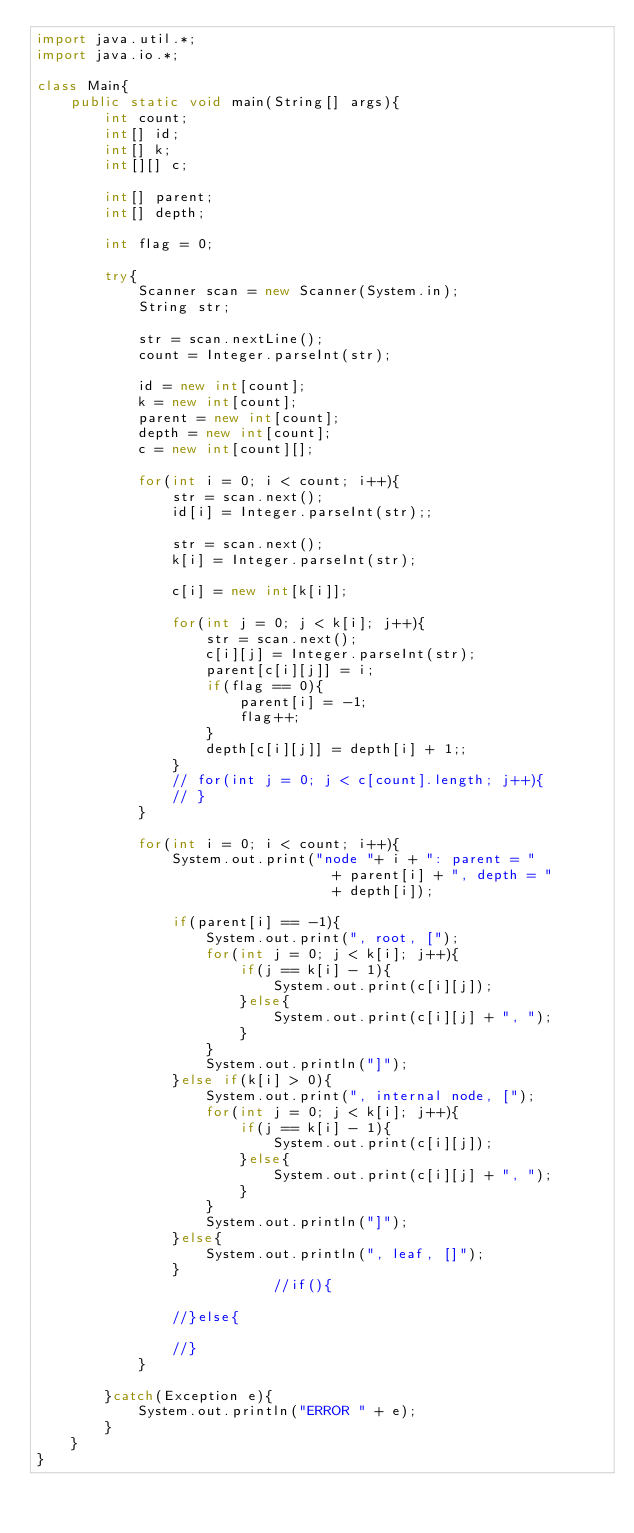<code> <loc_0><loc_0><loc_500><loc_500><_Java_>import java.util.*;
import java.io.*;

class Main{
    public static void main(String[] args){
        int count;
        int[] id;
        int[] k;
        int[][] c;

        int[] parent;
        int[] depth;

        int flag = 0;

        try{
            Scanner scan = new Scanner(System.in);
            String str;

            str = scan.nextLine();
            count = Integer.parseInt(str);

            id = new int[count];
            k = new int[count];
            parent = new int[count];
            depth = new int[count];
            c = new int[count][];

            for(int i = 0; i < count; i++){
                str = scan.next();
                id[i] = Integer.parseInt(str);;

                str = scan.next();
                k[i] = Integer.parseInt(str);

                c[i] = new int[k[i]];

                for(int j = 0; j < k[i]; j++){
                    str = scan.next();
                    c[i][j] = Integer.parseInt(str);
                    parent[c[i][j]] = i;
                    if(flag == 0){
                        parent[i] = -1;
                        flag++;
                    }
                    depth[c[i][j]] = depth[i] + 1;;
                }
                // for(int j = 0; j < c[count].length; j++){
                // }
            }

            for(int i = 0; i < count; i++){
                System.out.print("node "+ i + ": parent = "
                                   + parent[i] + ", depth = "
                                   + depth[i]);

                if(parent[i] == -1){
                    System.out.print(", root, [");
                    for(int j = 0; j < k[i]; j++){
                        if(j == k[i] - 1){
                            System.out.print(c[i][j]);
                        }else{
                            System.out.print(c[i][j] + ", ");
                        }
                    }
                    System.out.println("]");
                }else if(k[i] > 0){
                    System.out.print(", internal node, [");
                    for(int j = 0; j < k[i]; j++){
                        if(j == k[i] - 1){
                            System.out.print(c[i][j]);
                        }else{
                            System.out.print(c[i][j] + ", ");
                        }
                    }
                    System.out.println("]");
                }else{
                    System.out.println(", leaf, []");
                }
                            //if(){

                //}else{

                //}
            }

        }catch(Exception e){
            System.out.println("ERROR " + e);
        }
    }
}

</code> 